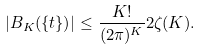Convert formula to latex. <formula><loc_0><loc_0><loc_500><loc_500>| B _ { K } ( \{ t \} ) | \leq \frac { K ! } { ( 2 \pi ) ^ { K } } 2 \zeta ( K ) .</formula> 